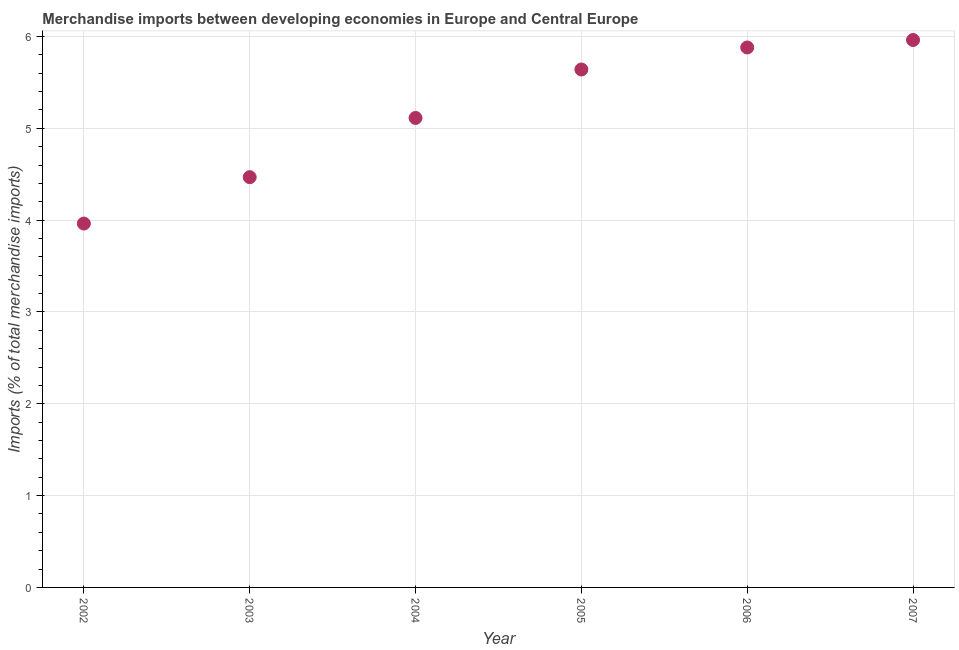What is the merchandise imports in 2006?
Ensure brevity in your answer.  5.88. Across all years, what is the maximum merchandise imports?
Ensure brevity in your answer.  5.96. Across all years, what is the minimum merchandise imports?
Your response must be concise. 3.96. In which year was the merchandise imports maximum?
Provide a succinct answer. 2007. In which year was the merchandise imports minimum?
Provide a short and direct response. 2002. What is the sum of the merchandise imports?
Offer a very short reply. 31.03. What is the difference between the merchandise imports in 2003 and 2007?
Offer a very short reply. -1.49. What is the average merchandise imports per year?
Give a very brief answer. 5.17. What is the median merchandise imports?
Keep it short and to the point. 5.38. What is the ratio of the merchandise imports in 2003 to that in 2004?
Make the answer very short. 0.87. What is the difference between the highest and the second highest merchandise imports?
Provide a succinct answer. 0.08. What is the difference between the highest and the lowest merchandise imports?
Make the answer very short. 2. In how many years, is the merchandise imports greater than the average merchandise imports taken over all years?
Provide a short and direct response. 3. Does the merchandise imports monotonically increase over the years?
Your answer should be very brief. Yes. How many dotlines are there?
Your answer should be very brief. 1. How many years are there in the graph?
Your answer should be compact. 6. What is the difference between two consecutive major ticks on the Y-axis?
Your response must be concise. 1. Are the values on the major ticks of Y-axis written in scientific E-notation?
Ensure brevity in your answer.  No. Does the graph contain grids?
Make the answer very short. Yes. What is the title of the graph?
Ensure brevity in your answer.  Merchandise imports between developing economies in Europe and Central Europe. What is the label or title of the X-axis?
Ensure brevity in your answer.  Year. What is the label or title of the Y-axis?
Provide a succinct answer. Imports (% of total merchandise imports). What is the Imports (% of total merchandise imports) in 2002?
Your answer should be very brief. 3.96. What is the Imports (% of total merchandise imports) in 2003?
Provide a succinct answer. 4.47. What is the Imports (% of total merchandise imports) in 2004?
Provide a short and direct response. 5.11. What is the Imports (% of total merchandise imports) in 2005?
Your answer should be compact. 5.64. What is the Imports (% of total merchandise imports) in 2006?
Give a very brief answer. 5.88. What is the Imports (% of total merchandise imports) in 2007?
Give a very brief answer. 5.96. What is the difference between the Imports (% of total merchandise imports) in 2002 and 2003?
Give a very brief answer. -0.51. What is the difference between the Imports (% of total merchandise imports) in 2002 and 2004?
Offer a terse response. -1.15. What is the difference between the Imports (% of total merchandise imports) in 2002 and 2005?
Make the answer very short. -1.68. What is the difference between the Imports (% of total merchandise imports) in 2002 and 2006?
Your answer should be compact. -1.92. What is the difference between the Imports (% of total merchandise imports) in 2002 and 2007?
Give a very brief answer. -2. What is the difference between the Imports (% of total merchandise imports) in 2003 and 2004?
Your answer should be very brief. -0.64. What is the difference between the Imports (% of total merchandise imports) in 2003 and 2005?
Your response must be concise. -1.17. What is the difference between the Imports (% of total merchandise imports) in 2003 and 2006?
Your answer should be compact. -1.41. What is the difference between the Imports (% of total merchandise imports) in 2003 and 2007?
Offer a terse response. -1.49. What is the difference between the Imports (% of total merchandise imports) in 2004 and 2005?
Provide a succinct answer. -0.53. What is the difference between the Imports (% of total merchandise imports) in 2004 and 2006?
Offer a terse response. -0.77. What is the difference between the Imports (% of total merchandise imports) in 2004 and 2007?
Provide a succinct answer. -0.85. What is the difference between the Imports (% of total merchandise imports) in 2005 and 2006?
Make the answer very short. -0.24. What is the difference between the Imports (% of total merchandise imports) in 2005 and 2007?
Provide a short and direct response. -0.32. What is the difference between the Imports (% of total merchandise imports) in 2006 and 2007?
Provide a succinct answer. -0.08. What is the ratio of the Imports (% of total merchandise imports) in 2002 to that in 2003?
Offer a very short reply. 0.89. What is the ratio of the Imports (% of total merchandise imports) in 2002 to that in 2004?
Offer a very short reply. 0.78. What is the ratio of the Imports (% of total merchandise imports) in 2002 to that in 2005?
Keep it short and to the point. 0.7. What is the ratio of the Imports (% of total merchandise imports) in 2002 to that in 2006?
Offer a very short reply. 0.67. What is the ratio of the Imports (% of total merchandise imports) in 2002 to that in 2007?
Provide a succinct answer. 0.67. What is the ratio of the Imports (% of total merchandise imports) in 2003 to that in 2004?
Provide a succinct answer. 0.87. What is the ratio of the Imports (% of total merchandise imports) in 2003 to that in 2005?
Make the answer very short. 0.79. What is the ratio of the Imports (% of total merchandise imports) in 2003 to that in 2006?
Give a very brief answer. 0.76. What is the ratio of the Imports (% of total merchandise imports) in 2003 to that in 2007?
Give a very brief answer. 0.75. What is the ratio of the Imports (% of total merchandise imports) in 2004 to that in 2005?
Provide a succinct answer. 0.91. What is the ratio of the Imports (% of total merchandise imports) in 2004 to that in 2006?
Keep it short and to the point. 0.87. What is the ratio of the Imports (% of total merchandise imports) in 2004 to that in 2007?
Make the answer very short. 0.86. What is the ratio of the Imports (% of total merchandise imports) in 2005 to that in 2007?
Offer a very short reply. 0.95. What is the ratio of the Imports (% of total merchandise imports) in 2006 to that in 2007?
Provide a succinct answer. 0.99. 